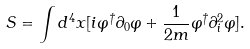Convert formula to latex. <formula><loc_0><loc_0><loc_500><loc_500>S = \int d ^ { 4 } x [ i \varphi ^ { \dagger } \partial _ { 0 } \varphi + \frac { 1 } { 2 m } \varphi ^ { \dagger } \partial _ { i } ^ { 2 } \varphi ] .</formula> 